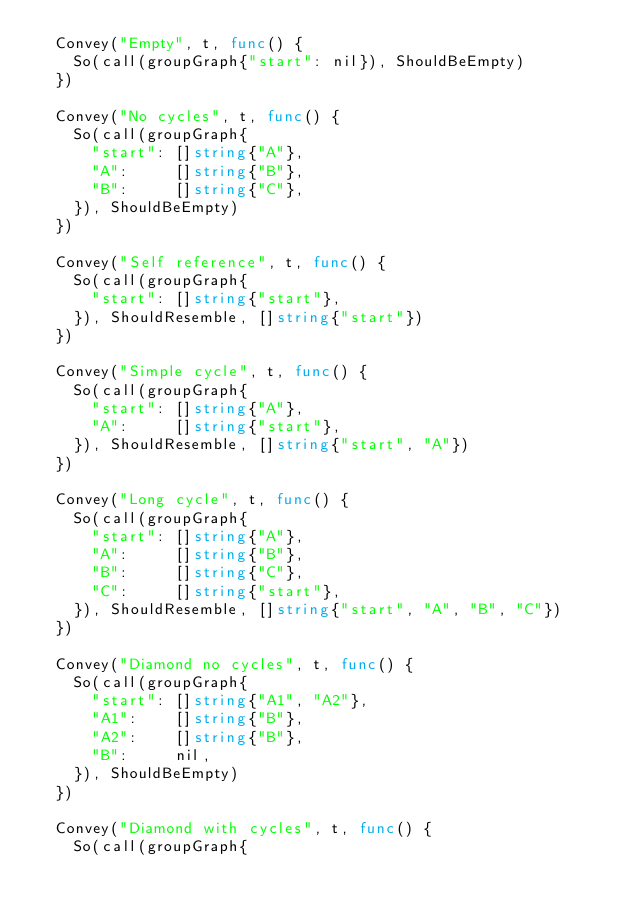Convert code to text. <code><loc_0><loc_0><loc_500><loc_500><_Go_>	Convey("Empty", t, func() {
		So(call(groupGraph{"start": nil}), ShouldBeEmpty)
	})

	Convey("No cycles", t, func() {
		So(call(groupGraph{
			"start": []string{"A"},
			"A":     []string{"B"},
			"B":     []string{"C"},
		}), ShouldBeEmpty)
	})

	Convey("Self reference", t, func() {
		So(call(groupGraph{
			"start": []string{"start"},
		}), ShouldResemble, []string{"start"})
	})

	Convey("Simple cycle", t, func() {
		So(call(groupGraph{
			"start": []string{"A"},
			"A":     []string{"start"},
		}), ShouldResemble, []string{"start", "A"})
	})

	Convey("Long cycle", t, func() {
		So(call(groupGraph{
			"start": []string{"A"},
			"A":     []string{"B"},
			"B":     []string{"C"},
			"C":     []string{"start"},
		}), ShouldResemble, []string{"start", "A", "B", "C"})
	})

	Convey("Diamond no cycles", t, func() {
		So(call(groupGraph{
			"start": []string{"A1", "A2"},
			"A1":    []string{"B"},
			"A2":    []string{"B"},
			"B":     nil,
		}), ShouldBeEmpty)
	})

	Convey("Diamond with cycles", t, func() {
		So(call(groupGraph{</code> 